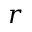Convert formula to latex. <formula><loc_0><loc_0><loc_500><loc_500>r</formula> 